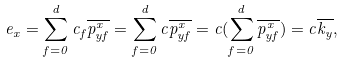<formula> <loc_0><loc_0><loc_500><loc_500>e _ { x } = \sum _ { f = 0 } ^ { d } c _ { f } \overline { p _ { y f } ^ { x } } = \sum _ { f = 0 } ^ { d } c \overline { p _ { y f } ^ { x } } = c ( \sum _ { f = 0 } ^ { d } \overline { p _ { y f } ^ { x } } ) = c \overline { k _ { y } } ,</formula> 